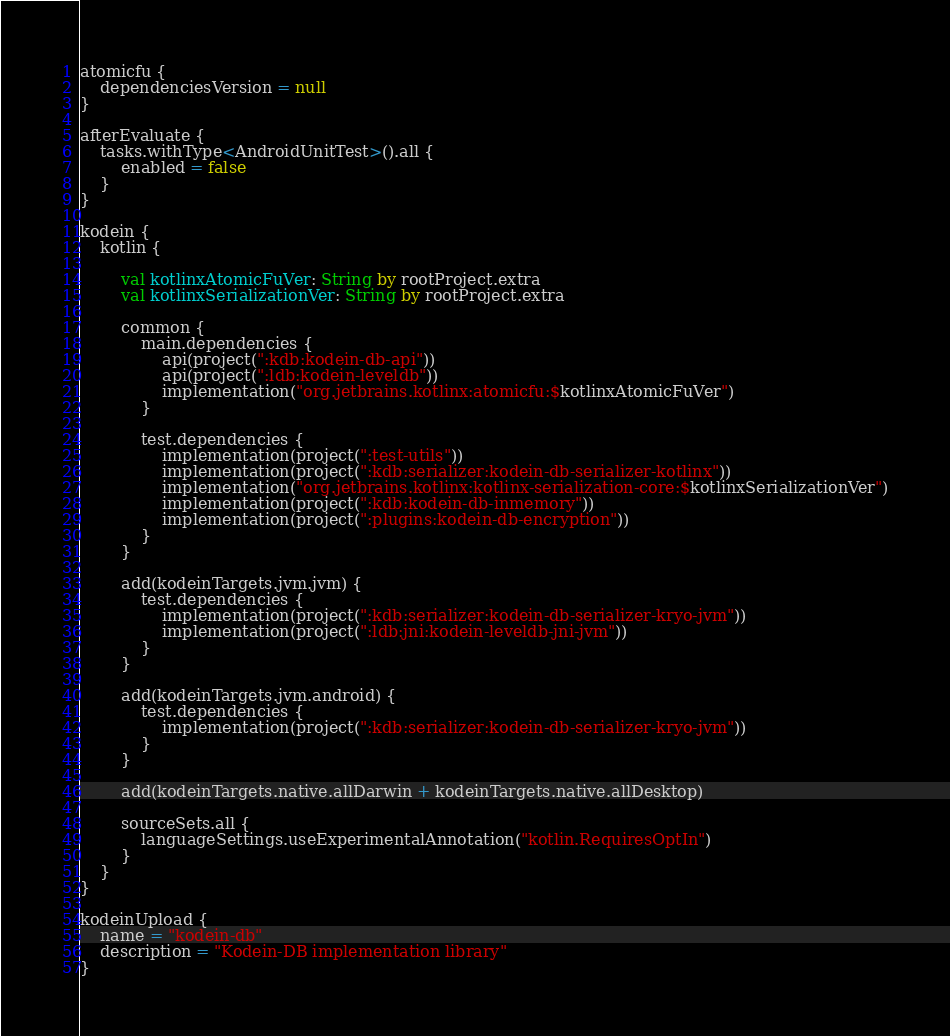<code> <loc_0><loc_0><loc_500><loc_500><_Kotlin_>atomicfu {
    dependenciesVersion = null
}

afterEvaluate {
    tasks.withType<AndroidUnitTest>().all {
        enabled = false
    }
}

kodein {
    kotlin {

        val kotlinxAtomicFuVer: String by rootProject.extra
        val kotlinxSerializationVer: String by rootProject.extra

        common {
            main.dependencies {
                api(project(":kdb:kodein-db-api"))
                api(project(":ldb:kodein-leveldb"))
                implementation("org.jetbrains.kotlinx:atomicfu:$kotlinxAtomicFuVer")
            }

            test.dependencies {
                implementation(project(":test-utils"))
                implementation(project(":kdb:serializer:kodein-db-serializer-kotlinx"))
                implementation("org.jetbrains.kotlinx:kotlinx-serialization-core:$kotlinxSerializationVer")
                implementation(project(":kdb:kodein-db-inmemory"))
                implementation(project(":plugins:kodein-db-encryption"))
            }
        }

        add(kodeinTargets.jvm.jvm) {
            test.dependencies {
                implementation(project(":kdb:serializer:kodein-db-serializer-kryo-jvm"))
                implementation(project(":ldb:jni:kodein-leveldb-jni-jvm"))
            }
        }

        add(kodeinTargets.jvm.android) {
            test.dependencies {
                implementation(project(":kdb:serializer:kodein-db-serializer-kryo-jvm"))
            }
        }

        add(kodeinTargets.native.allDarwin + kodeinTargets.native.allDesktop)

        sourceSets.all {
            languageSettings.useExperimentalAnnotation("kotlin.RequiresOptIn")
        }
    }
}

kodeinUpload {
    name = "kodein-db"
    description = "Kodein-DB implementation library"
}</code> 